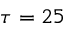<formula> <loc_0><loc_0><loc_500><loc_500>\tau = 2 5</formula> 